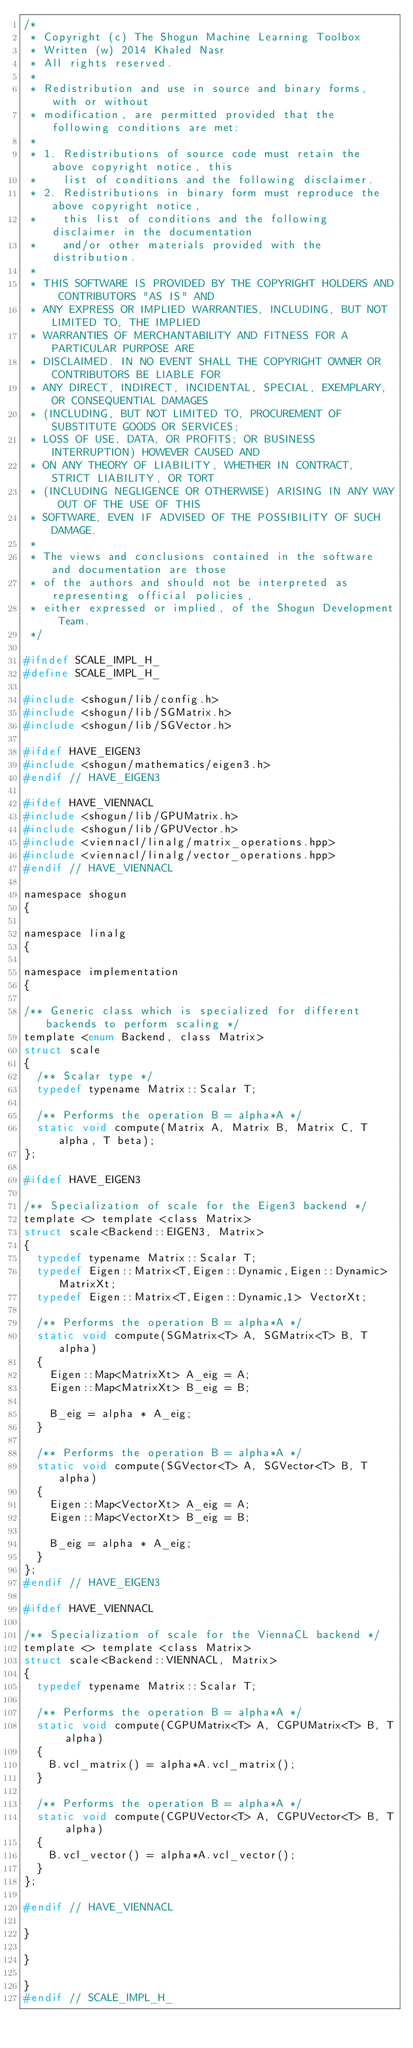<code> <loc_0><loc_0><loc_500><loc_500><_C_>/*
 * Copyright (c) The Shogun Machine Learning Toolbox
 * Written (w) 2014 Khaled Nasr
 * All rights reserved.
 *
 * Redistribution and use in source and binary forms, with or without
 * modification, are permitted provided that the following conditions are met:
 *
 * 1. Redistributions of source code must retain the above copyright notice, this
 *    list of conditions and the following disclaimer.
 * 2. Redistributions in binary form must reproduce the above copyright notice,
 *    this list of conditions and the following disclaimer in the documentation
 *    and/or other materials provided with the distribution.
 *
 * THIS SOFTWARE IS PROVIDED BY THE COPYRIGHT HOLDERS AND CONTRIBUTORS "AS IS" AND
 * ANY EXPRESS OR IMPLIED WARRANTIES, INCLUDING, BUT NOT LIMITED TO, THE IMPLIED
 * WARRANTIES OF MERCHANTABILITY AND FITNESS FOR A PARTICULAR PURPOSE ARE
 * DISCLAIMED. IN NO EVENT SHALL THE COPYRIGHT OWNER OR CONTRIBUTORS BE LIABLE FOR
 * ANY DIRECT, INDIRECT, INCIDENTAL, SPECIAL, EXEMPLARY, OR CONSEQUENTIAL DAMAGES
 * (INCLUDING, BUT NOT LIMITED TO, PROCUREMENT OF SUBSTITUTE GOODS OR SERVICES;
 * LOSS OF USE, DATA, OR PROFITS; OR BUSINESS INTERRUPTION) HOWEVER CAUSED AND
 * ON ANY THEORY OF LIABILITY, WHETHER IN CONTRACT, STRICT LIABILITY, OR TORT
 * (INCLUDING NEGLIGENCE OR OTHERWISE) ARISING IN ANY WAY OUT OF THE USE OF THIS
 * SOFTWARE, EVEN IF ADVISED OF THE POSSIBILITY OF SUCH DAMAGE.
 *
 * The views and conclusions contained in the software and documentation are those
 * of the authors and should not be interpreted as representing official policies,
 * either expressed or implied, of the Shogun Development Team.
 */

#ifndef SCALE_IMPL_H_
#define SCALE_IMPL_H_

#include <shogun/lib/config.h>
#include <shogun/lib/SGMatrix.h>
#include <shogun/lib/SGVector.h>

#ifdef HAVE_EIGEN3
#include <shogun/mathematics/eigen3.h>
#endif // HAVE_EIGEN3

#ifdef HAVE_VIENNACL
#include <shogun/lib/GPUMatrix.h>
#include <shogun/lib/GPUVector.h>
#include <viennacl/linalg/matrix_operations.hpp>
#include <viennacl/linalg/vector_operations.hpp>
#endif // HAVE_VIENNACL

namespace shogun
{

namespace linalg
{

namespace implementation
{

/** Generic class which is specialized for different backends to perform scaling */
template <enum Backend, class Matrix>
struct scale
{
	/** Scalar type */
	typedef typename Matrix::Scalar T;
	
	/** Performs the operation B = alpha*A */
	static void compute(Matrix A, Matrix B, Matrix C, T alpha, T beta);
};

#ifdef HAVE_EIGEN3

/** Specialization of scale for the Eigen3 backend */
template <> template <class Matrix>
struct scale<Backend::EIGEN3, Matrix>
{
	typedef typename Matrix::Scalar T;
	typedef Eigen::Matrix<T,Eigen::Dynamic,Eigen::Dynamic> MatrixXt;
	typedef Eigen::Matrix<T,Eigen::Dynamic,1> VectorXt;
	
	/** Performs the operation B = alpha*A */
	static void compute(SGMatrix<T> A, SGMatrix<T> B, T alpha)
	{
		Eigen::Map<MatrixXt> A_eig = A;
		Eigen::Map<MatrixXt> B_eig = B;
		
		B_eig = alpha * A_eig;
	}
	
	/** Performs the operation B = alpha*A */
	static void compute(SGVector<T> A, SGVector<T> B, T alpha)
	{
		Eigen::Map<VectorXt> A_eig = A;
		Eigen::Map<VectorXt> B_eig = B;
		
		B_eig = alpha * A_eig;
	}
};
#endif // HAVE_EIGEN3

#ifdef HAVE_VIENNACL

/** Specialization of scale for the ViennaCL backend */
template <> template <class Matrix>
struct scale<Backend::VIENNACL, Matrix>
{
	typedef typename Matrix::Scalar T;
	
	/** Performs the operation B = alpha*A */
	static void compute(CGPUMatrix<T> A, CGPUMatrix<T> B, T alpha)
	{
		B.vcl_matrix() = alpha*A.vcl_matrix();
	}
	
	/** Performs the operation B = alpha*A */
	static void compute(CGPUVector<T> A, CGPUVector<T> B, T alpha)
	{
		B.vcl_vector() = alpha*A.vcl_vector();
	}
};

#endif // HAVE_VIENNACL

}

}

}
#endif // SCALE_IMPL_H_
</code> 